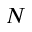Convert formula to latex. <formula><loc_0><loc_0><loc_500><loc_500>N</formula> 